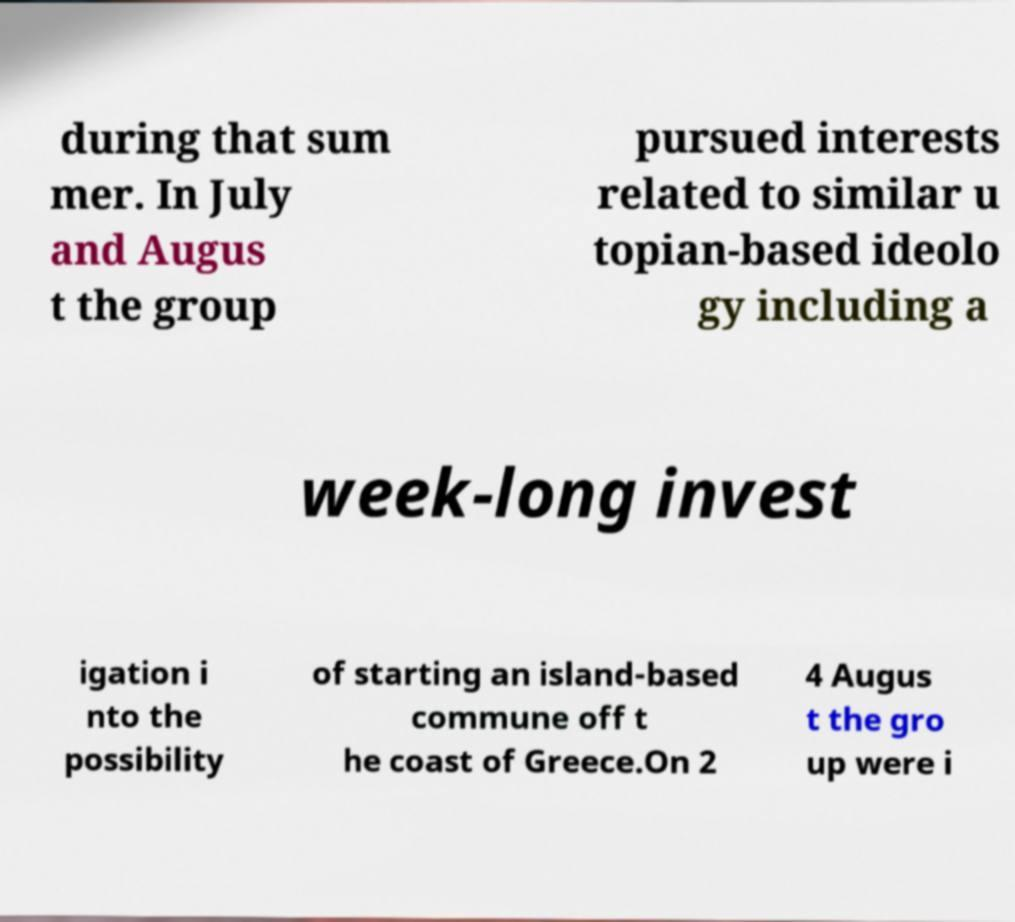Can you read and provide the text displayed in the image?This photo seems to have some interesting text. Can you extract and type it out for me? during that sum mer. In July and Augus t the group pursued interests related to similar u topian-based ideolo gy including a week-long invest igation i nto the possibility of starting an island-based commune off t he coast of Greece.On 2 4 Augus t the gro up were i 